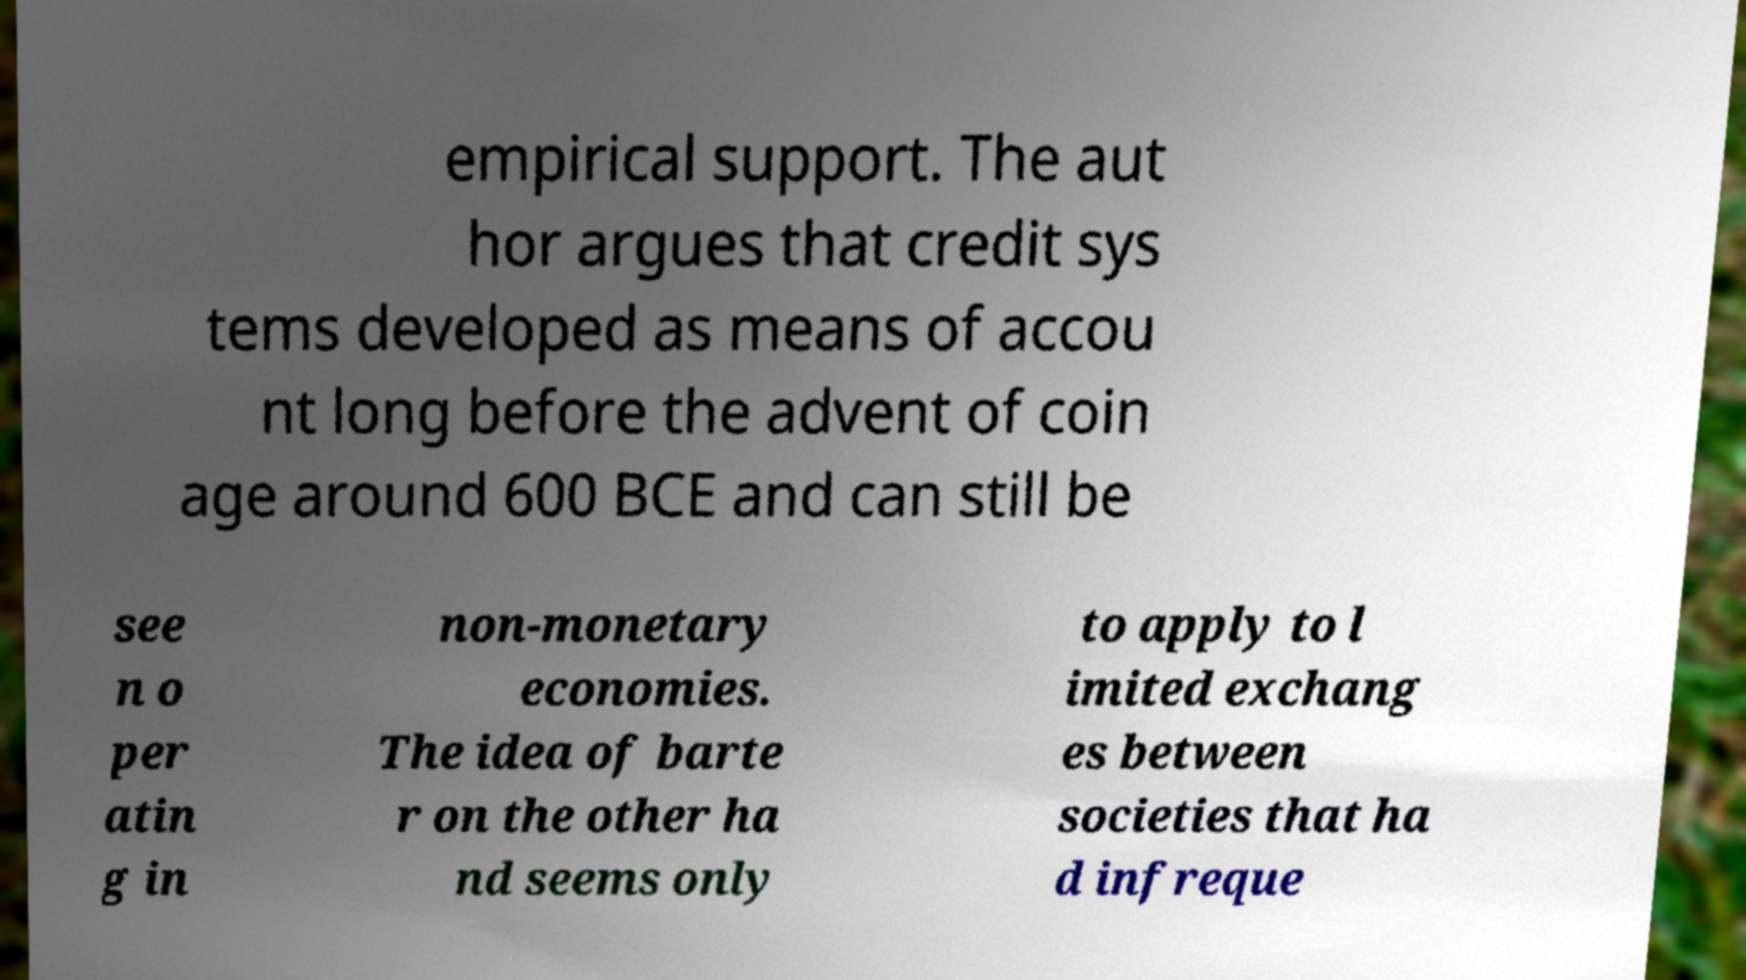For documentation purposes, I need the text within this image transcribed. Could you provide that? empirical support. The aut hor argues that credit sys tems developed as means of accou nt long before the advent of coin age around 600 BCE and can still be see n o per atin g in non-monetary economies. The idea of barte r on the other ha nd seems only to apply to l imited exchang es between societies that ha d infreque 